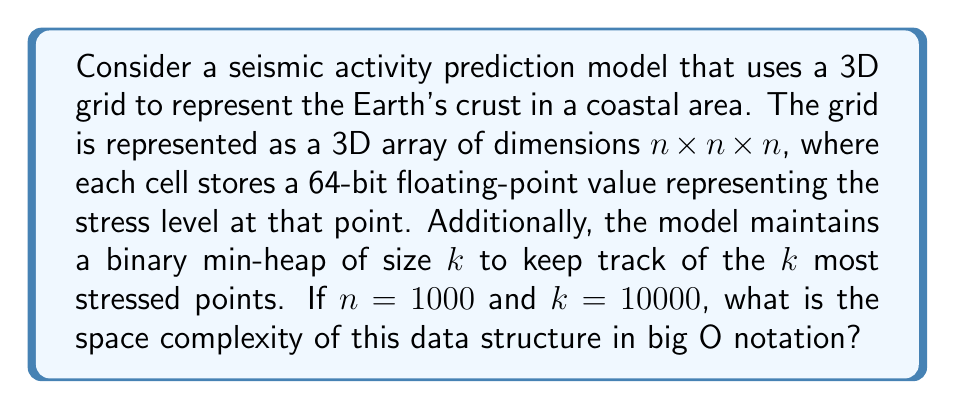What is the answer to this math problem? To evaluate the space complexity, we need to consider the storage requirements for both the 3D grid and the binary min-heap:

1. 3D Grid:
   - Dimensions: $n \times n \times n$
   - Each cell stores a 64-bit (8-byte) floating-point value
   - Total space for grid = $n^3 \times 8$ bytes
   - With $n = 1000$, this becomes $1000^3 \times 8 = 8 \times 10^9$ bytes

2. Binary Min-Heap:
   - Size of heap: $k$
   - Each element in the heap typically stores:
     a) A 64-bit floating-point value (8 bytes)
     b) Three 32-bit integers for coordinates (12 bytes)
   - Total space for heap = $k \times (8 + 12)$ bytes
   - With $k = 10000$, this becomes $10000 \times 20 = 2 \times 10^5$ bytes

The total space requirement is the sum of these two components:
$$(8 \times 10^9) + (2 \times 10^5) \approx 8 \times 10^9 \text{ bytes}$$

In big O notation, we express this in terms of $n$ and $k$:
$$O(n^3 + k)$$

Since $k$ is much smaller than $n^3$ in this case (and in most practical scenarios for this application), we can simplify this to:
$$O(n^3)$$

This represents the dominant term in the space complexity.
Answer: $O(n^3)$ 